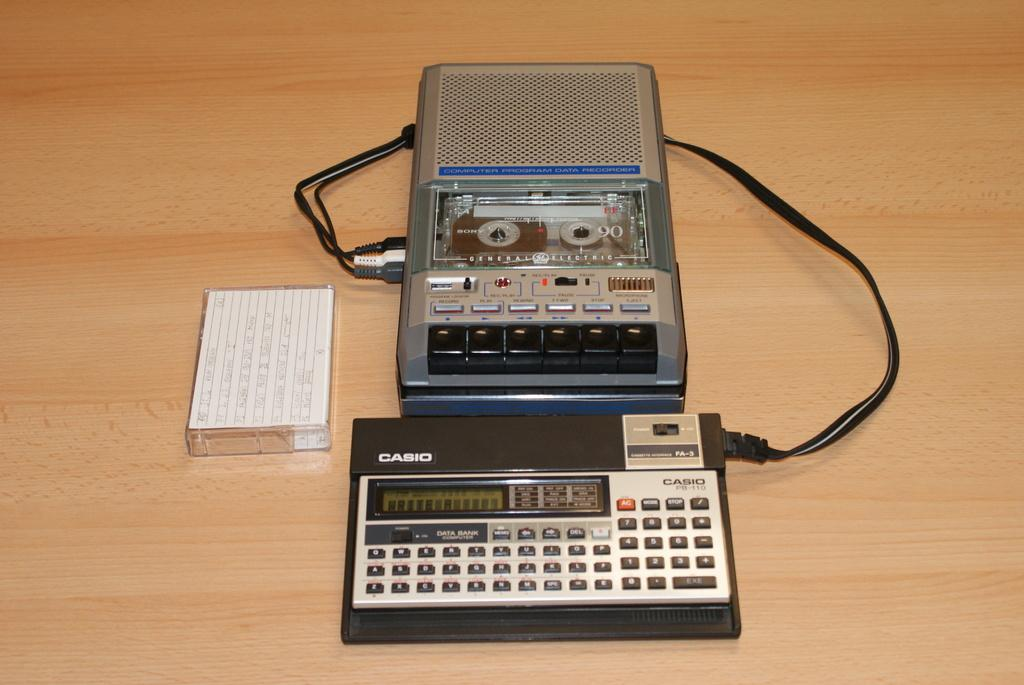<image>
Write a terse but informative summary of the picture. A tape recorder is hooked into a small Casio keyboard. 